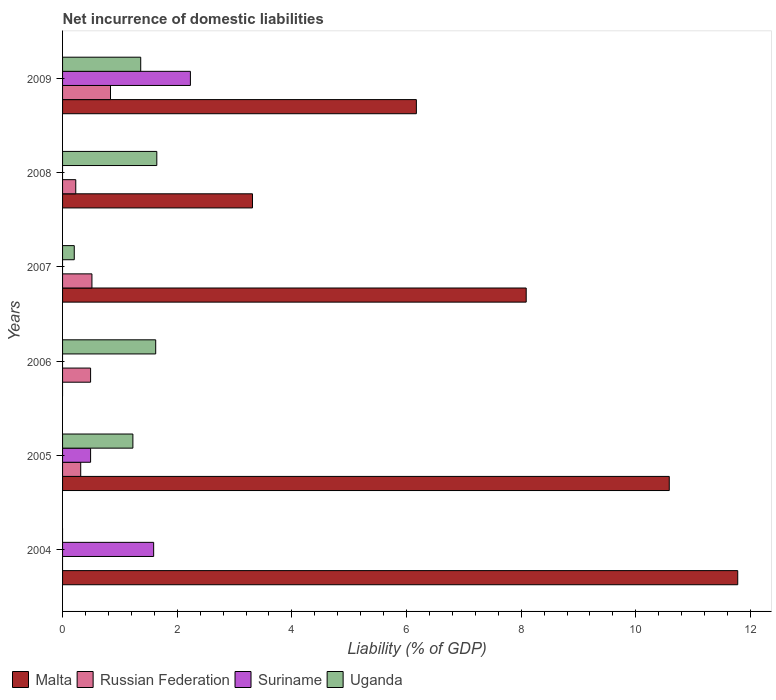How many bars are there on the 3rd tick from the bottom?
Offer a terse response. 2. What is the label of the 3rd group of bars from the top?
Keep it short and to the point. 2007. In how many cases, is the number of bars for a given year not equal to the number of legend labels?
Offer a very short reply. 4. What is the net incurrence of domestic liabilities in Russian Federation in 2008?
Offer a very short reply. 0.23. Across all years, what is the maximum net incurrence of domestic liabilities in Uganda?
Provide a succinct answer. 1.64. Across all years, what is the minimum net incurrence of domestic liabilities in Suriname?
Your answer should be very brief. 0. In which year was the net incurrence of domestic liabilities in Suriname maximum?
Offer a terse response. 2009. What is the total net incurrence of domestic liabilities in Uganda in the graph?
Provide a succinct answer. 6.06. What is the difference between the net incurrence of domestic liabilities in Malta in 2005 and that in 2007?
Keep it short and to the point. 2.5. What is the difference between the net incurrence of domestic liabilities in Malta in 2006 and the net incurrence of domestic liabilities in Suriname in 2007?
Provide a succinct answer. 0. What is the average net incurrence of domestic liabilities in Russian Federation per year?
Make the answer very short. 0.4. In the year 2009, what is the difference between the net incurrence of domestic liabilities in Malta and net incurrence of domestic liabilities in Suriname?
Ensure brevity in your answer.  3.94. What is the ratio of the net incurrence of domestic liabilities in Malta in 2004 to that in 2007?
Ensure brevity in your answer.  1.46. What is the difference between the highest and the second highest net incurrence of domestic liabilities in Malta?
Provide a succinct answer. 1.19. What is the difference between the highest and the lowest net incurrence of domestic liabilities in Malta?
Offer a very short reply. 11.78. In how many years, is the net incurrence of domestic liabilities in Suriname greater than the average net incurrence of domestic liabilities in Suriname taken over all years?
Make the answer very short. 2. Is the sum of the net incurrence of domestic liabilities in Malta in 2004 and 2008 greater than the maximum net incurrence of domestic liabilities in Uganda across all years?
Your answer should be very brief. Yes. How many bars are there?
Ensure brevity in your answer.  18. How many years are there in the graph?
Your answer should be very brief. 6. How are the legend labels stacked?
Your answer should be very brief. Horizontal. What is the title of the graph?
Your answer should be compact. Net incurrence of domestic liabilities. What is the label or title of the X-axis?
Your answer should be compact. Liability (% of GDP). What is the label or title of the Y-axis?
Provide a succinct answer. Years. What is the Liability (% of GDP) of Malta in 2004?
Offer a terse response. 11.78. What is the Liability (% of GDP) in Suriname in 2004?
Your answer should be compact. 1.59. What is the Liability (% of GDP) in Malta in 2005?
Make the answer very short. 10.58. What is the Liability (% of GDP) of Russian Federation in 2005?
Your answer should be compact. 0.32. What is the Liability (% of GDP) in Suriname in 2005?
Offer a terse response. 0.49. What is the Liability (% of GDP) of Uganda in 2005?
Your response must be concise. 1.23. What is the Liability (% of GDP) in Russian Federation in 2006?
Make the answer very short. 0.49. What is the Liability (% of GDP) in Suriname in 2006?
Give a very brief answer. 0. What is the Liability (% of GDP) of Uganda in 2006?
Ensure brevity in your answer.  1.62. What is the Liability (% of GDP) of Malta in 2007?
Make the answer very short. 8.09. What is the Liability (% of GDP) in Russian Federation in 2007?
Provide a succinct answer. 0.51. What is the Liability (% of GDP) of Suriname in 2007?
Your answer should be compact. 0. What is the Liability (% of GDP) of Uganda in 2007?
Give a very brief answer. 0.2. What is the Liability (% of GDP) of Malta in 2008?
Give a very brief answer. 3.31. What is the Liability (% of GDP) of Russian Federation in 2008?
Provide a short and direct response. 0.23. What is the Liability (% of GDP) of Uganda in 2008?
Make the answer very short. 1.64. What is the Liability (% of GDP) of Malta in 2009?
Offer a terse response. 6.17. What is the Liability (% of GDP) of Russian Federation in 2009?
Provide a succinct answer. 0.84. What is the Liability (% of GDP) of Suriname in 2009?
Offer a very short reply. 2.23. What is the Liability (% of GDP) of Uganda in 2009?
Keep it short and to the point. 1.36. Across all years, what is the maximum Liability (% of GDP) in Malta?
Your response must be concise. 11.78. Across all years, what is the maximum Liability (% of GDP) in Russian Federation?
Your response must be concise. 0.84. Across all years, what is the maximum Liability (% of GDP) in Suriname?
Offer a terse response. 2.23. Across all years, what is the maximum Liability (% of GDP) of Uganda?
Your answer should be compact. 1.64. Across all years, what is the minimum Liability (% of GDP) of Malta?
Provide a short and direct response. 0. Across all years, what is the minimum Liability (% of GDP) in Russian Federation?
Your response must be concise. 0. What is the total Liability (% of GDP) of Malta in the graph?
Provide a succinct answer. 39.94. What is the total Liability (% of GDP) of Russian Federation in the graph?
Your answer should be very brief. 2.38. What is the total Liability (% of GDP) of Suriname in the graph?
Provide a short and direct response. 4.31. What is the total Liability (% of GDP) of Uganda in the graph?
Keep it short and to the point. 6.06. What is the difference between the Liability (% of GDP) in Malta in 2004 and that in 2005?
Provide a short and direct response. 1.19. What is the difference between the Liability (% of GDP) in Suriname in 2004 and that in 2005?
Your answer should be compact. 1.1. What is the difference between the Liability (% of GDP) of Malta in 2004 and that in 2007?
Make the answer very short. 3.69. What is the difference between the Liability (% of GDP) of Malta in 2004 and that in 2008?
Provide a succinct answer. 8.47. What is the difference between the Liability (% of GDP) in Malta in 2004 and that in 2009?
Keep it short and to the point. 5.61. What is the difference between the Liability (% of GDP) of Suriname in 2004 and that in 2009?
Provide a short and direct response. -0.64. What is the difference between the Liability (% of GDP) in Russian Federation in 2005 and that in 2006?
Offer a terse response. -0.17. What is the difference between the Liability (% of GDP) in Uganda in 2005 and that in 2006?
Provide a short and direct response. -0.4. What is the difference between the Liability (% of GDP) of Malta in 2005 and that in 2007?
Your answer should be compact. 2.5. What is the difference between the Liability (% of GDP) in Russian Federation in 2005 and that in 2007?
Your answer should be compact. -0.2. What is the difference between the Liability (% of GDP) of Uganda in 2005 and that in 2007?
Give a very brief answer. 1.02. What is the difference between the Liability (% of GDP) of Malta in 2005 and that in 2008?
Your answer should be compact. 7.27. What is the difference between the Liability (% of GDP) of Russian Federation in 2005 and that in 2008?
Offer a very short reply. 0.09. What is the difference between the Liability (% of GDP) of Uganda in 2005 and that in 2008?
Ensure brevity in your answer.  -0.42. What is the difference between the Liability (% of GDP) in Malta in 2005 and that in 2009?
Your answer should be very brief. 4.41. What is the difference between the Liability (% of GDP) of Russian Federation in 2005 and that in 2009?
Your answer should be very brief. -0.52. What is the difference between the Liability (% of GDP) in Suriname in 2005 and that in 2009?
Provide a short and direct response. -1.74. What is the difference between the Liability (% of GDP) in Uganda in 2005 and that in 2009?
Keep it short and to the point. -0.14. What is the difference between the Liability (% of GDP) of Russian Federation in 2006 and that in 2007?
Keep it short and to the point. -0.02. What is the difference between the Liability (% of GDP) of Uganda in 2006 and that in 2007?
Your answer should be compact. 1.42. What is the difference between the Liability (% of GDP) of Russian Federation in 2006 and that in 2008?
Provide a succinct answer. 0.26. What is the difference between the Liability (% of GDP) of Uganda in 2006 and that in 2008?
Offer a very short reply. -0.02. What is the difference between the Liability (% of GDP) in Russian Federation in 2006 and that in 2009?
Offer a terse response. -0.35. What is the difference between the Liability (% of GDP) in Uganda in 2006 and that in 2009?
Provide a short and direct response. 0.26. What is the difference between the Liability (% of GDP) in Malta in 2007 and that in 2008?
Your response must be concise. 4.78. What is the difference between the Liability (% of GDP) in Russian Federation in 2007 and that in 2008?
Provide a succinct answer. 0.28. What is the difference between the Liability (% of GDP) of Uganda in 2007 and that in 2008?
Make the answer very short. -1.44. What is the difference between the Liability (% of GDP) in Malta in 2007 and that in 2009?
Offer a very short reply. 1.92. What is the difference between the Liability (% of GDP) in Russian Federation in 2007 and that in 2009?
Give a very brief answer. -0.32. What is the difference between the Liability (% of GDP) in Uganda in 2007 and that in 2009?
Keep it short and to the point. -1.16. What is the difference between the Liability (% of GDP) in Malta in 2008 and that in 2009?
Offer a terse response. -2.86. What is the difference between the Liability (% of GDP) of Russian Federation in 2008 and that in 2009?
Your response must be concise. -0.61. What is the difference between the Liability (% of GDP) in Uganda in 2008 and that in 2009?
Provide a succinct answer. 0.28. What is the difference between the Liability (% of GDP) in Malta in 2004 and the Liability (% of GDP) in Russian Federation in 2005?
Offer a very short reply. 11.46. What is the difference between the Liability (% of GDP) in Malta in 2004 and the Liability (% of GDP) in Suriname in 2005?
Keep it short and to the point. 11.29. What is the difference between the Liability (% of GDP) of Malta in 2004 and the Liability (% of GDP) of Uganda in 2005?
Your answer should be compact. 10.55. What is the difference between the Liability (% of GDP) of Suriname in 2004 and the Liability (% of GDP) of Uganda in 2005?
Offer a terse response. 0.36. What is the difference between the Liability (% of GDP) of Malta in 2004 and the Liability (% of GDP) of Russian Federation in 2006?
Ensure brevity in your answer.  11.29. What is the difference between the Liability (% of GDP) of Malta in 2004 and the Liability (% of GDP) of Uganda in 2006?
Give a very brief answer. 10.15. What is the difference between the Liability (% of GDP) of Suriname in 2004 and the Liability (% of GDP) of Uganda in 2006?
Offer a terse response. -0.04. What is the difference between the Liability (% of GDP) of Malta in 2004 and the Liability (% of GDP) of Russian Federation in 2007?
Your response must be concise. 11.27. What is the difference between the Liability (% of GDP) of Malta in 2004 and the Liability (% of GDP) of Uganda in 2007?
Give a very brief answer. 11.57. What is the difference between the Liability (% of GDP) in Suriname in 2004 and the Liability (% of GDP) in Uganda in 2007?
Provide a short and direct response. 1.39. What is the difference between the Liability (% of GDP) in Malta in 2004 and the Liability (% of GDP) in Russian Federation in 2008?
Offer a terse response. 11.55. What is the difference between the Liability (% of GDP) of Malta in 2004 and the Liability (% of GDP) of Uganda in 2008?
Provide a short and direct response. 10.13. What is the difference between the Liability (% of GDP) of Suriname in 2004 and the Liability (% of GDP) of Uganda in 2008?
Ensure brevity in your answer.  -0.06. What is the difference between the Liability (% of GDP) of Malta in 2004 and the Liability (% of GDP) of Russian Federation in 2009?
Ensure brevity in your answer.  10.94. What is the difference between the Liability (% of GDP) of Malta in 2004 and the Liability (% of GDP) of Suriname in 2009?
Keep it short and to the point. 9.55. What is the difference between the Liability (% of GDP) in Malta in 2004 and the Liability (% of GDP) in Uganda in 2009?
Keep it short and to the point. 10.42. What is the difference between the Liability (% of GDP) in Suriname in 2004 and the Liability (% of GDP) in Uganda in 2009?
Offer a terse response. 0.23. What is the difference between the Liability (% of GDP) of Malta in 2005 and the Liability (% of GDP) of Russian Federation in 2006?
Your answer should be compact. 10.1. What is the difference between the Liability (% of GDP) in Malta in 2005 and the Liability (% of GDP) in Uganda in 2006?
Give a very brief answer. 8.96. What is the difference between the Liability (% of GDP) of Russian Federation in 2005 and the Liability (% of GDP) of Uganda in 2006?
Offer a terse response. -1.31. What is the difference between the Liability (% of GDP) in Suriname in 2005 and the Liability (% of GDP) in Uganda in 2006?
Your answer should be very brief. -1.14. What is the difference between the Liability (% of GDP) in Malta in 2005 and the Liability (% of GDP) in Russian Federation in 2007?
Offer a very short reply. 10.07. What is the difference between the Liability (% of GDP) in Malta in 2005 and the Liability (% of GDP) in Uganda in 2007?
Give a very brief answer. 10.38. What is the difference between the Liability (% of GDP) of Russian Federation in 2005 and the Liability (% of GDP) of Uganda in 2007?
Ensure brevity in your answer.  0.11. What is the difference between the Liability (% of GDP) in Suriname in 2005 and the Liability (% of GDP) in Uganda in 2007?
Provide a succinct answer. 0.28. What is the difference between the Liability (% of GDP) of Malta in 2005 and the Liability (% of GDP) of Russian Federation in 2008?
Give a very brief answer. 10.35. What is the difference between the Liability (% of GDP) in Malta in 2005 and the Liability (% of GDP) in Uganda in 2008?
Your answer should be very brief. 8.94. What is the difference between the Liability (% of GDP) of Russian Federation in 2005 and the Liability (% of GDP) of Uganda in 2008?
Your response must be concise. -1.33. What is the difference between the Liability (% of GDP) of Suriname in 2005 and the Liability (% of GDP) of Uganda in 2008?
Offer a very short reply. -1.16. What is the difference between the Liability (% of GDP) in Malta in 2005 and the Liability (% of GDP) in Russian Federation in 2009?
Keep it short and to the point. 9.75. What is the difference between the Liability (% of GDP) of Malta in 2005 and the Liability (% of GDP) of Suriname in 2009?
Keep it short and to the point. 8.35. What is the difference between the Liability (% of GDP) in Malta in 2005 and the Liability (% of GDP) in Uganda in 2009?
Keep it short and to the point. 9.22. What is the difference between the Liability (% of GDP) in Russian Federation in 2005 and the Liability (% of GDP) in Suriname in 2009?
Offer a very short reply. -1.91. What is the difference between the Liability (% of GDP) of Russian Federation in 2005 and the Liability (% of GDP) of Uganda in 2009?
Provide a short and direct response. -1.05. What is the difference between the Liability (% of GDP) of Suriname in 2005 and the Liability (% of GDP) of Uganda in 2009?
Keep it short and to the point. -0.87. What is the difference between the Liability (% of GDP) in Russian Federation in 2006 and the Liability (% of GDP) in Uganda in 2007?
Give a very brief answer. 0.28. What is the difference between the Liability (% of GDP) in Russian Federation in 2006 and the Liability (% of GDP) in Uganda in 2008?
Provide a succinct answer. -1.16. What is the difference between the Liability (% of GDP) in Russian Federation in 2006 and the Liability (% of GDP) in Suriname in 2009?
Give a very brief answer. -1.74. What is the difference between the Liability (% of GDP) of Russian Federation in 2006 and the Liability (% of GDP) of Uganda in 2009?
Give a very brief answer. -0.87. What is the difference between the Liability (% of GDP) in Malta in 2007 and the Liability (% of GDP) in Russian Federation in 2008?
Your response must be concise. 7.86. What is the difference between the Liability (% of GDP) of Malta in 2007 and the Liability (% of GDP) of Uganda in 2008?
Offer a terse response. 6.44. What is the difference between the Liability (% of GDP) of Russian Federation in 2007 and the Liability (% of GDP) of Uganda in 2008?
Your answer should be very brief. -1.13. What is the difference between the Liability (% of GDP) of Malta in 2007 and the Liability (% of GDP) of Russian Federation in 2009?
Ensure brevity in your answer.  7.25. What is the difference between the Liability (% of GDP) of Malta in 2007 and the Liability (% of GDP) of Suriname in 2009?
Keep it short and to the point. 5.86. What is the difference between the Liability (% of GDP) of Malta in 2007 and the Liability (% of GDP) of Uganda in 2009?
Your answer should be compact. 6.72. What is the difference between the Liability (% of GDP) in Russian Federation in 2007 and the Liability (% of GDP) in Suriname in 2009?
Make the answer very short. -1.72. What is the difference between the Liability (% of GDP) of Russian Federation in 2007 and the Liability (% of GDP) of Uganda in 2009?
Offer a very short reply. -0.85. What is the difference between the Liability (% of GDP) in Malta in 2008 and the Liability (% of GDP) in Russian Federation in 2009?
Keep it short and to the point. 2.48. What is the difference between the Liability (% of GDP) in Malta in 2008 and the Liability (% of GDP) in Suriname in 2009?
Offer a terse response. 1.08. What is the difference between the Liability (% of GDP) in Malta in 2008 and the Liability (% of GDP) in Uganda in 2009?
Offer a terse response. 1.95. What is the difference between the Liability (% of GDP) in Russian Federation in 2008 and the Liability (% of GDP) in Uganda in 2009?
Ensure brevity in your answer.  -1.13. What is the average Liability (% of GDP) in Malta per year?
Your response must be concise. 6.66. What is the average Liability (% of GDP) in Russian Federation per year?
Make the answer very short. 0.4. What is the average Liability (% of GDP) of Suriname per year?
Your response must be concise. 0.72. What is the average Liability (% of GDP) of Uganda per year?
Make the answer very short. 1.01. In the year 2004, what is the difference between the Liability (% of GDP) in Malta and Liability (% of GDP) in Suriname?
Your response must be concise. 10.19. In the year 2005, what is the difference between the Liability (% of GDP) in Malta and Liability (% of GDP) in Russian Federation?
Your answer should be compact. 10.27. In the year 2005, what is the difference between the Liability (% of GDP) of Malta and Liability (% of GDP) of Suriname?
Your answer should be very brief. 10.1. In the year 2005, what is the difference between the Liability (% of GDP) of Malta and Liability (% of GDP) of Uganda?
Offer a terse response. 9.36. In the year 2005, what is the difference between the Liability (% of GDP) in Russian Federation and Liability (% of GDP) in Suriname?
Give a very brief answer. -0.17. In the year 2005, what is the difference between the Liability (% of GDP) in Russian Federation and Liability (% of GDP) in Uganda?
Offer a terse response. -0.91. In the year 2005, what is the difference between the Liability (% of GDP) of Suriname and Liability (% of GDP) of Uganda?
Provide a short and direct response. -0.74. In the year 2006, what is the difference between the Liability (% of GDP) in Russian Federation and Liability (% of GDP) in Uganda?
Offer a terse response. -1.14. In the year 2007, what is the difference between the Liability (% of GDP) of Malta and Liability (% of GDP) of Russian Federation?
Keep it short and to the point. 7.58. In the year 2007, what is the difference between the Liability (% of GDP) in Malta and Liability (% of GDP) in Uganda?
Your answer should be very brief. 7.88. In the year 2007, what is the difference between the Liability (% of GDP) in Russian Federation and Liability (% of GDP) in Uganda?
Offer a very short reply. 0.31. In the year 2008, what is the difference between the Liability (% of GDP) of Malta and Liability (% of GDP) of Russian Federation?
Provide a short and direct response. 3.08. In the year 2008, what is the difference between the Liability (% of GDP) of Malta and Liability (% of GDP) of Uganda?
Your answer should be compact. 1.67. In the year 2008, what is the difference between the Liability (% of GDP) of Russian Federation and Liability (% of GDP) of Uganda?
Your response must be concise. -1.41. In the year 2009, what is the difference between the Liability (% of GDP) of Malta and Liability (% of GDP) of Russian Federation?
Offer a very short reply. 5.34. In the year 2009, what is the difference between the Liability (% of GDP) in Malta and Liability (% of GDP) in Suriname?
Offer a terse response. 3.94. In the year 2009, what is the difference between the Liability (% of GDP) of Malta and Liability (% of GDP) of Uganda?
Ensure brevity in your answer.  4.81. In the year 2009, what is the difference between the Liability (% of GDP) in Russian Federation and Liability (% of GDP) in Suriname?
Provide a short and direct response. -1.39. In the year 2009, what is the difference between the Liability (% of GDP) in Russian Federation and Liability (% of GDP) in Uganda?
Your answer should be compact. -0.53. In the year 2009, what is the difference between the Liability (% of GDP) in Suriname and Liability (% of GDP) in Uganda?
Offer a very short reply. 0.87. What is the ratio of the Liability (% of GDP) in Malta in 2004 to that in 2005?
Your response must be concise. 1.11. What is the ratio of the Liability (% of GDP) of Suriname in 2004 to that in 2005?
Give a very brief answer. 3.25. What is the ratio of the Liability (% of GDP) in Malta in 2004 to that in 2007?
Keep it short and to the point. 1.46. What is the ratio of the Liability (% of GDP) of Malta in 2004 to that in 2008?
Keep it short and to the point. 3.56. What is the ratio of the Liability (% of GDP) in Malta in 2004 to that in 2009?
Provide a short and direct response. 1.91. What is the ratio of the Liability (% of GDP) of Suriname in 2004 to that in 2009?
Your answer should be compact. 0.71. What is the ratio of the Liability (% of GDP) of Russian Federation in 2005 to that in 2006?
Your answer should be very brief. 0.65. What is the ratio of the Liability (% of GDP) of Uganda in 2005 to that in 2006?
Provide a succinct answer. 0.76. What is the ratio of the Liability (% of GDP) of Malta in 2005 to that in 2007?
Provide a short and direct response. 1.31. What is the ratio of the Liability (% of GDP) in Russian Federation in 2005 to that in 2007?
Make the answer very short. 0.62. What is the ratio of the Liability (% of GDP) in Uganda in 2005 to that in 2007?
Make the answer very short. 6.01. What is the ratio of the Liability (% of GDP) in Malta in 2005 to that in 2008?
Provide a short and direct response. 3.19. What is the ratio of the Liability (% of GDP) in Russian Federation in 2005 to that in 2008?
Your answer should be compact. 1.38. What is the ratio of the Liability (% of GDP) of Uganda in 2005 to that in 2008?
Offer a very short reply. 0.75. What is the ratio of the Liability (% of GDP) in Malta in 2005 to that in 2009?
Ensure brevity in your answer.  1.71. What is the ratio of the Liability (% of GDP) of Russian Federation in 2005 to that in 2009?
Offer a very short reply. 0.38. What is the ratio of the Liability (% of GDP) in Suriname in 2005 to that in 2009?
Offer a terse response. 0.22. What is the ratio of the Liability (% of GDP) in Uganda in 2005 to that in 2009?
Your answer should be compact. 0.9. What is the ratio of the Liability (% of GDP) of Russian Federation in 2006 to that in 2007?
Your answer should be compact. 0.95. What is the ratio of the Liability (% of GDP) of Uganda in 2006 to that in 2007?
Provide a short and direct response. 7.96. What is the ratio of the Liability (% of GDP) in Russian Federation in 2006 to that in 2008?
Provide a short and direct response. 2.12. What is the ratio of the Liability (% of GDP) in Russian Federation in 2006 to that in 2009?
Give a very brief answer. 0.58. What is the ratio of the Liability (% of GDP) of Uganda in 2006 to that in 2009?
Provide a short and direct response. 1.19. What is the ratio of the Liability (% of GDP) in Malta in 2007 to that in 2008?
Ensure brevity in your answer.  2.44. What is the ratio of the Liability (% of GDP) in Russian Federation in 2007 to that in 2008?
Ensure brevity in your answer.  2.23. What is the ratio of the Liability (% of GDP) in Uganda in 2007 to that in 2008?
Provide a short and direct response. 0.12. What is the ratio of the Liability (% of GDP) in Malta in 2007 to that in 2009?
Make the answer very short. 1.31. What is the ratio of the Liability (% of GDP) of Russian Federation in 2007 to that in 2009?
Give a very brief answer. 0.61. What is the ratio of the Liability (% of GDP) of Uganda in 2007 to that in 2009?
Offer a very short reply. 0.15. What is the ratio of the Liability (% of GDP) of Malta in 2008 to that in 2009?
Provide a succinct answer. 0.54. What is the ratio of the Liability (% of GDP) in Russian Federation in 2008 to that in 2009?
Offer a terse response. 0.28. What is the ratio of the Liability (% of GDP) in Uganda in 2008 to that in 2009?
Your answer should be very brief. 1.21. What is the difference between the highest and the second highest Liability (% of GDP) of Malta?
Make the answer very short. 1.19. What is the difference between the highest and the second highest Liability (% of GDP) of Russian Federation?
Offer a terse response. 0.32. What is the difference between the highest and the second highest Liability (% of GDP) of Suriname?
Make the answer very short. 0.64. What is the difference between the highest and the second highest Liability (% of GDP) of Uganda?
Your answer should be very brief. 0.02. What is the difference between the highest and the lowest Liability (% of GDP) in Malta?
Offer a terse response. 11.78. What is the difference between the highest and the lowest Liability (% of GDP) in Russian Federation?
Your response must be concise. 0.84. What is the difference between the highest and the lowest Liability (% of GDP) of Suriname?
Keep it short and to the point. 2.23. What is the difference between the highest and the lowest Liability (% of GDP) in Uganda?
Provide a succinct answer. 1.64. 